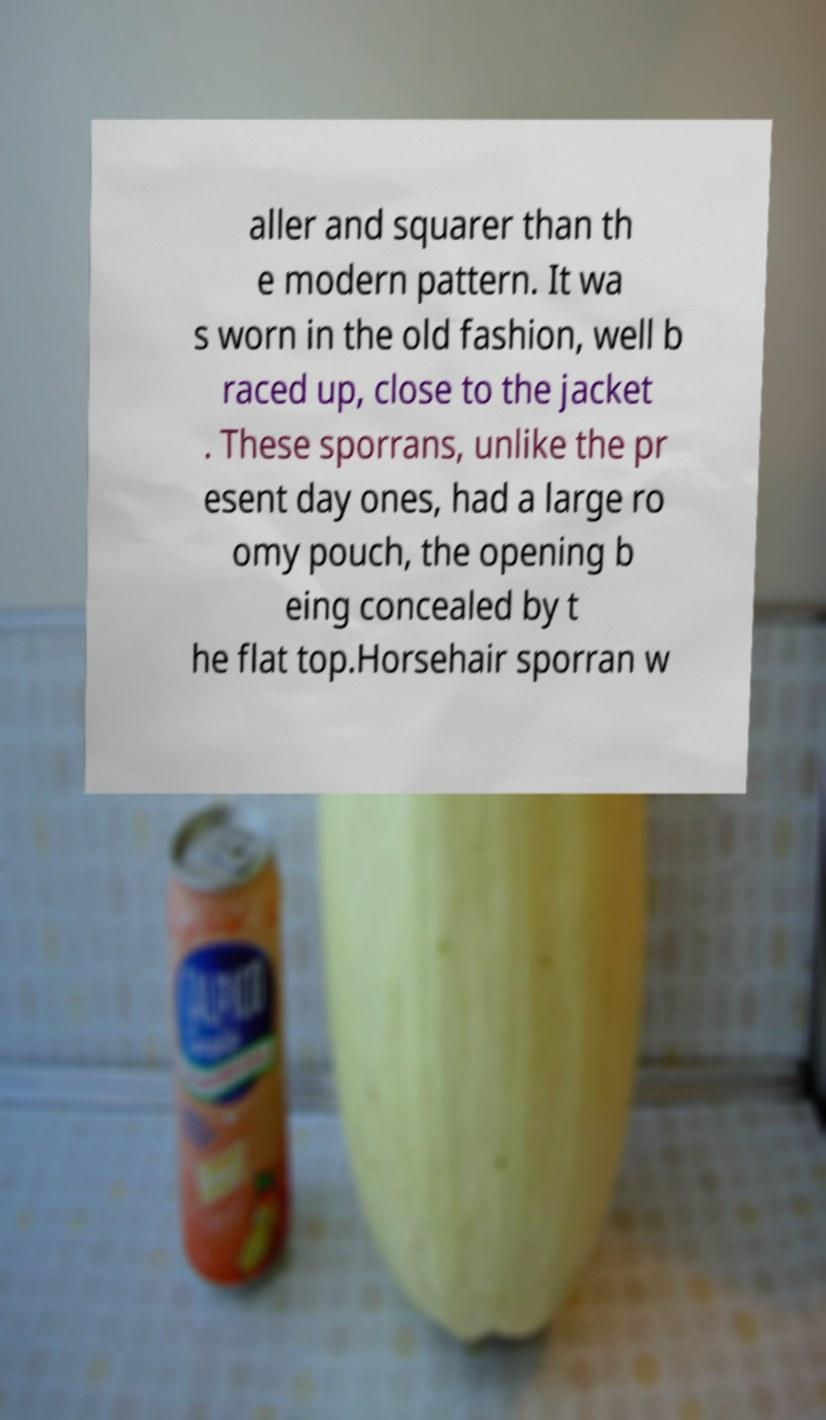For documentation purposes, I need the text within this image transcribed. Could you provide that? aller and squarer than th e modern pattern. It wa s worn in the old fashion, well b raced up, close to the jacket . These sporrans, unlike the pr esent day ones, had a large ro omy pouch, the opening b eing concealed by t he flat top.Horsehair sporran w 